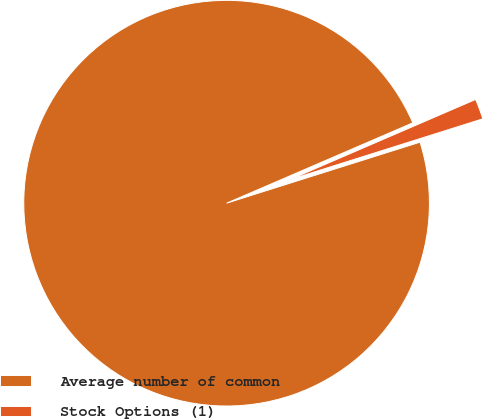<chart> <loc_0><loc_0><loc_500><loc_500><pie_chart><fcel>Average number of common<fcel>Stock Options (1)<nl><fcel>98.38%<fcel>1.62%<nl></chart> 